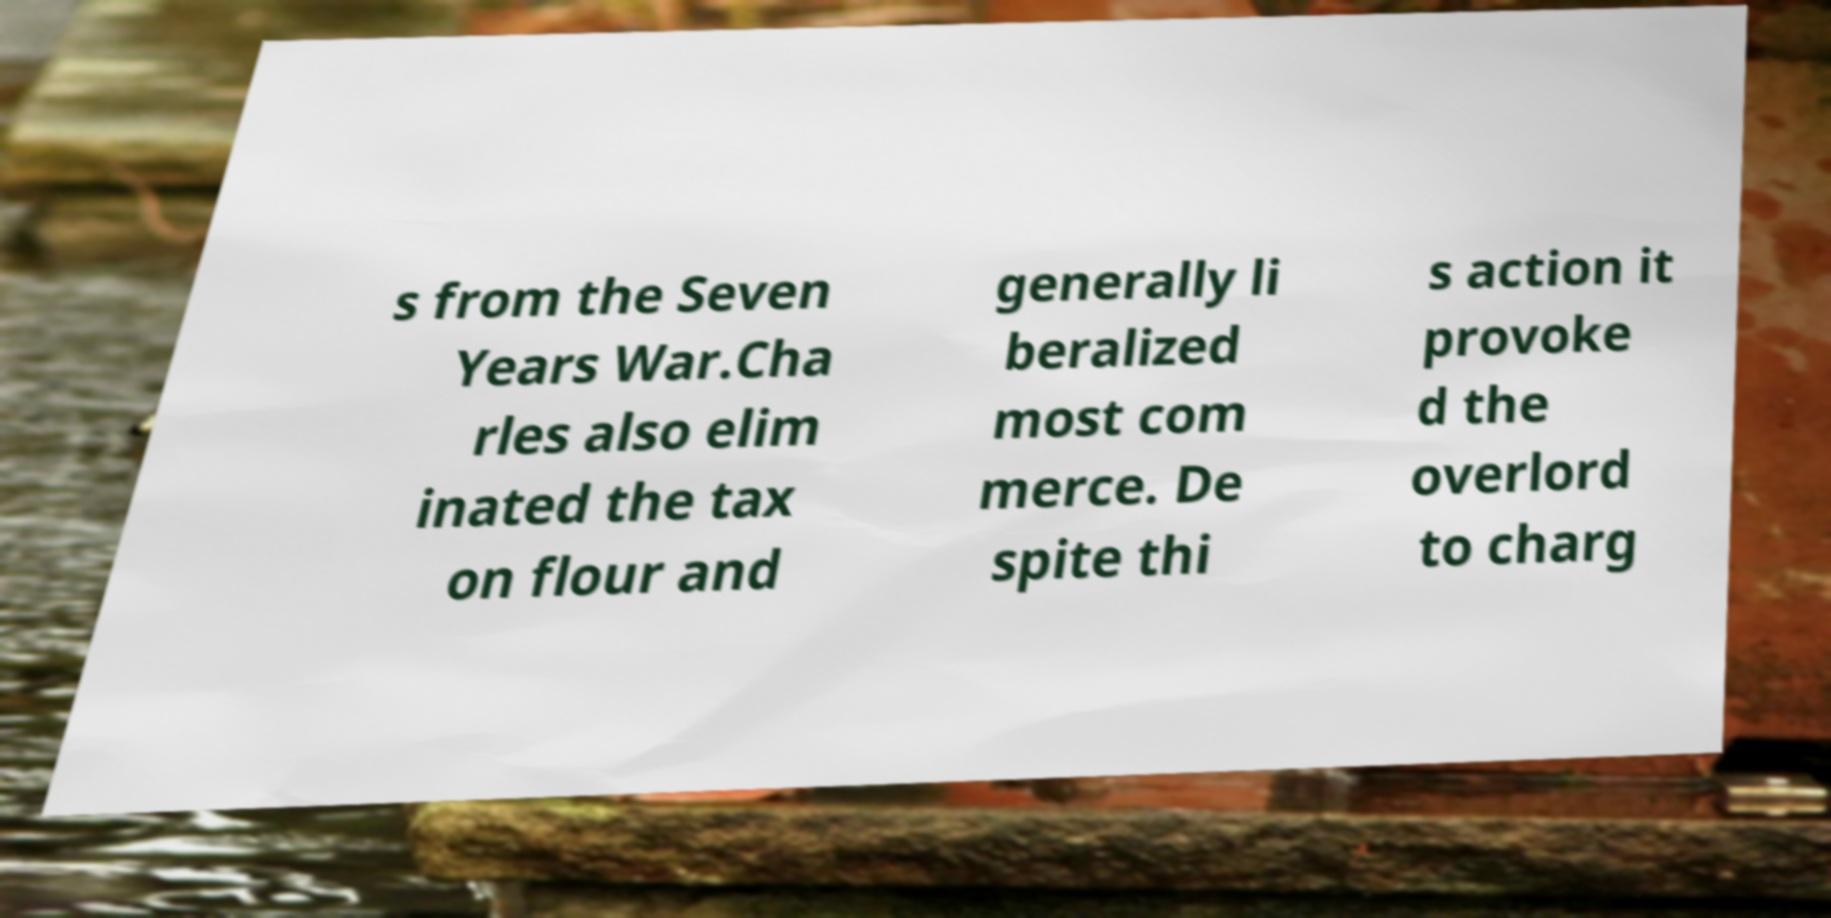Can you accurately transcribe the text from the provided image for me? s from the Seven Years War.Cha rles also elim inated the tax on flour and generally li beralized most com merce. De spite thi s action it provoke d the overlord to charg 